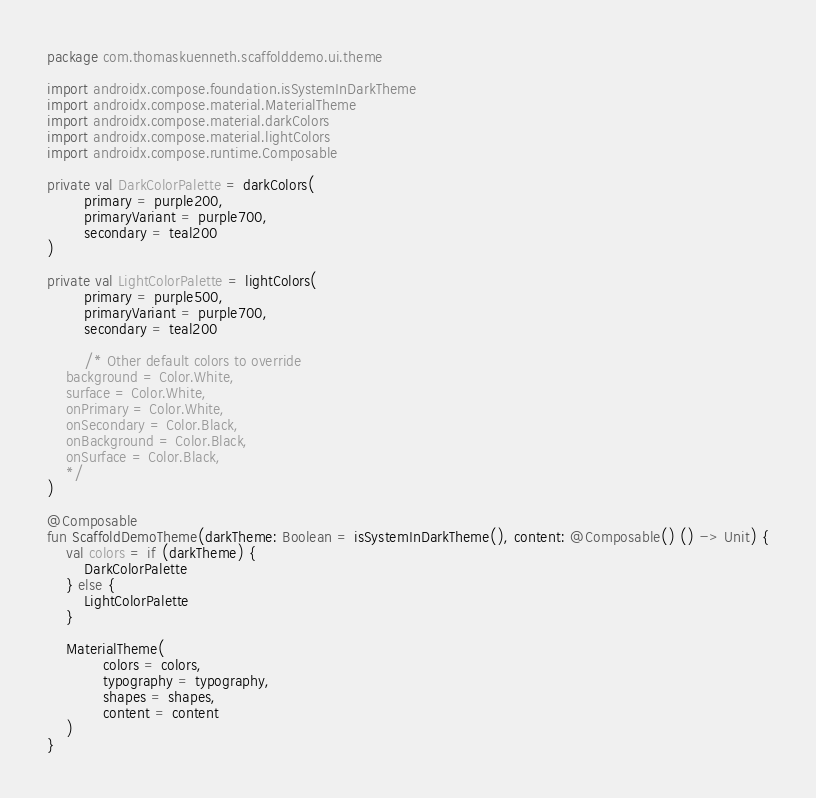<code> <loc_0><loc_0><loc_500><loc_500><_Kotlin_>package com.thomaskuenneth.scaffolddemo.ui.theme

import androidx.compose.foundation.isSystemInDarkTheme
import androidx.compose.material.MaterialTheme
import androidx.compose.material.darkColors
import androidx.compose.material.lightColors
import androidx.compose.runtime.Composable

private val DarkColorPalette = darkColors(
        primary = purple200,
        primaryVariant = purple700,
        secondary = teal200
)

private val LightColorPalette = lightColors(
        primary = purple500,
        primaryVariant = purple700,
        secondary = teal200

        /* Other default colors to override
    background = Color.White,
    surface = Color.White,
    onPrimary = Color.White,
    onSecondary = Color.Black,
    onBackground = Color.Black,
    onSurface = Color.Black,
    */
)

@Composable
fun ScaffoldDemoTheme(darkTheme: Boolean = isSystemInDarkTheme(), content: @Composable() () -> Unit) {
    val colors = if (darkTheme) {
        DarkColorPalette
    } else {
        LightColorPalette
    }

    MaterialTheme(
            colors = colors,
            typography = typography,
            shapes = shapes,
            content = content
    )
}</code> 